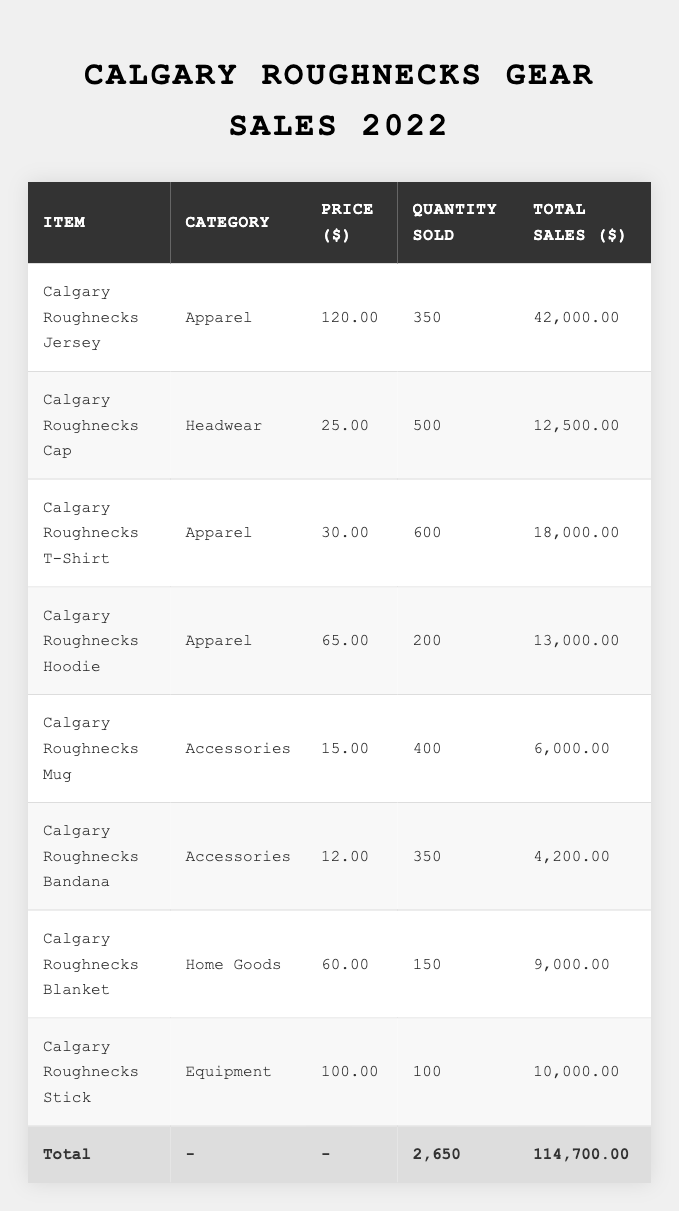What is the total quantity of Calgary Roughnecks merchandise sold? The total quantity sold can be found by summing the "Quantity Sold" column. This includes: 350 (jersey) + 500 (cap) + 600 (t-shirt) + 200 (hoodie) + 400 (mug) + 350 (bandana) + 150 (blanket) + 100 (stick) = 2,650.
Answer: 2,650 What is the total sales revenue for the Calgary Roughnecks merchandise? The total sales revenue is given at the bottom of the "Total Sales ($)" column. By adding the sales of all items, we see that the total sales amount to $114,700.00.
Answer: $114,700.00 Which item had the highest total sales revenue? Looking at the "Total Sales ($)" column, the Calgary Roughnecks Jersey has the highest total sales, amounting to $42,000.00.
Answer: Calgary Roughnecks Jersey How many more Calgary Roughnecks Caps were sold compared to Hoodies? The Caps sold are 500, while the Hoodies sold are 200. The difference is 500 - 200 = 300.
Answer: 300 What is the average price of the apparel items sold? The apparel items are the Jersey ($120.00), T-Shirt ($30.00), and Hoodie ($65.00). To find the average, sum these prices: 120 + 30 + 65 = 215, and then divide by the number of apparel items (3): 215/3 ≈ 71.67.
Answer: 71.67 Did the total sales for Accessories exceed those for Apparel? Total sales for Accessories (Mug + Bandana) are $6,000 + $4,200 = $10,200. For Apparel (Jersey + T-Shirt + Hoodie), total sales are $42,000 + $18,000 + $13,000 = $73,000. Since $10,200 is less than $73,000, the statement is false.
Answer: No What percentage of total sales does the Calgary Roughnecks Jersey account for? The total sales are $114,700. The sales for the Jersey are $42,000. To find the percentage, (42,000 / 114,700) * 100 ≈ 36.6%.
Answer: 36.6% How many times more Calgary Roughnecks Caps were sold than Blankets? Caps sold are 500, and Blankets sold are 150. To find how many times more, divide: 500 / 150 ≈ 3.33.
Answer: 3.33 What is the total sales revenue for the Equipment category? The only item in the Equipment category is the Calgary Roughnecks Stick, which has total sales of $10,000.
Answer: $10,000 How many items sold in the Apparel category were sold in total? The total number sold in Apparel includes the Jersey (350), T-Shirt (600), and Hoodie (200). Therefore, 350 + 600 + 200 = 1,150 sold.
Answer: 1,150 